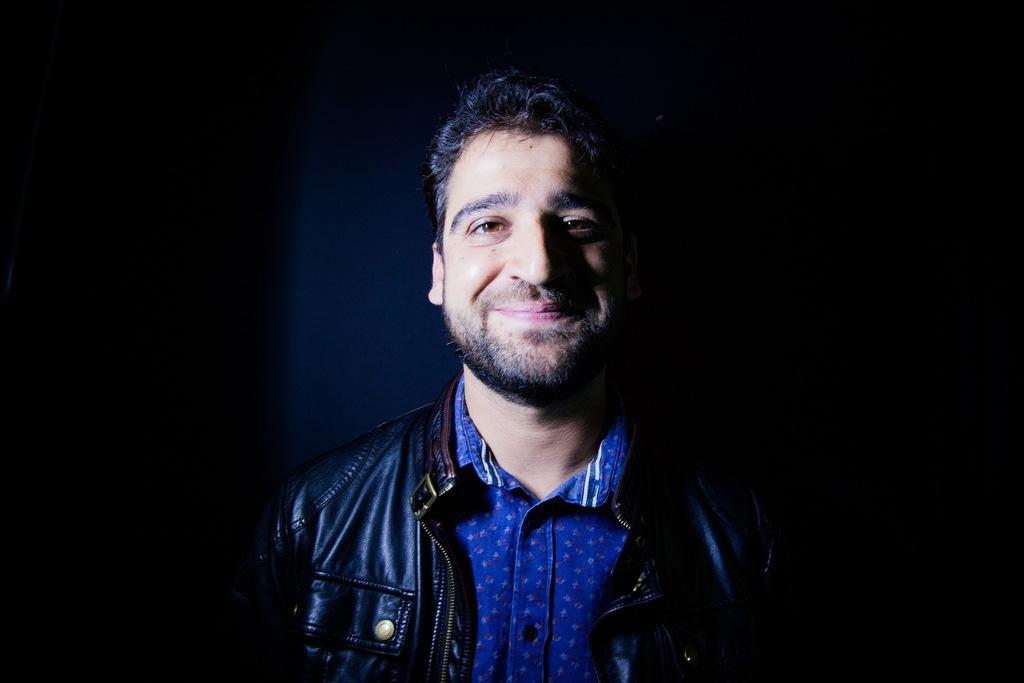What is the main subject of the image? The main subject of the image is a man. Can you describe the man's position in the image? The man is in the center of the image. What type of lettuce can be seen flying in the image? There is no lettuce present in the image, and therefore no such activity can be observed. 